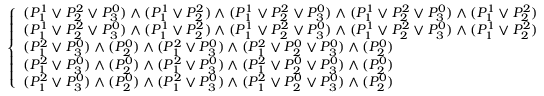Convert formula to latex. <formula><loc_0><loc_0><loc_500><loc_500>{ \left \{ \begin{array} { l l } { ( P _ { 1 } ^ { 1 } \lor P _ { 2 } ^ { 2 } \lor P _ { 3 } ^ { 0 } ) \land ( P _ { 1 } ^ { 1 } \lor P _ { 2 } ^ { 2 } ) \land ( P _ { 1 } ^ { 1 } \lor P _ { 2 } ^ { 2 } \lor P _ { 3 } ^ { 0 } ) \land ( P _ { 1 } ^ { 1 } \lor P _ { 2 } ^ { 2 } \lor P _ { 3 } ^ { 0 } ) \land ( P _ { 1 } ^ { 1 } \lor P _ { 2 } ^ { 2 } ) } \\ { ( P _ { 1 } ^ { 1 } \lor P _ { 2 } ^ { 2 } \lor P _ { 3 } ^ { 0 } ) \land ( P _ { 1 } ^ { 1 } \lor P _ { 2 } ^ { 2 } ) \land ( P _ { 1 } ^ { 1 } \lor P _ { 2 } ^ { 2 } \lor P _ { 3 } ^ { 0 } ) \land ( P _ { 1 } ^ { 1 } \lor P _ { 2 } ^ { 2 } \lor P _ { 3 } ^ { 0 } ) \land ( P _ { 1 } ^ { 1 } \lor P _ { 2 } ^ { 2 } ) } \\ { ( P _ { 1 } ^ { 2 } \lor P _ { 3 } ^ { 0 } ) \land ( P _ { 2 } ^ { 0 } ) \land ( P _ { 1 } ^ { 2 } \lor P _ { 3 } ^ { 0 } ) \land ( P _ { 1 } ^ { 2 } \lor P _ { 2 } ^ { 0 } \lor P _ { 3 } ^ { 0 } ) \land ( P _ { 2 } ^ { 0 } ) } \\ { ( P _ { 1 } ^ { 2 } \lor P _ { 3 } ^ { 0 } ) \land ( P _ { 2 } ^ { 0 } ) \land ( P _ { 1 } ^ { 2 } \lor P _ { 3 } ^ { 0 } ) \land ( P _ { 1 } ^ { 2 } \lor P _ { 2 } ^ { 0 } \lor P _ { 3 } ^ { 0 } ) \land ( P _ { 2 } ^ { 0 } ) } \\ { ( P _ { 1 } ^ { 2 } \lor P _ { 3 } ^ { 0 } ) \land ( P _ { 2 } ^ { 0 } ) \land ( P _ { 1 } ^ { 2 } \lor P _ { 3 } ^ { 0 } ) \land ( P _ { 1 } ^ { 2 } \lor P _ { 2 } ^ { 0 } \lor P _ { 3 } ^ { 0 } ) \land ( P _ { 2 } ^ { 0 } ) } \end{array} }</formula> 